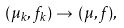<formula> <loc_0><loc_0><loc_500><loc_500>( \mu _ { k } , \, f _ { k } ) \to \, ( \mu , \, f ) ,</formula> 